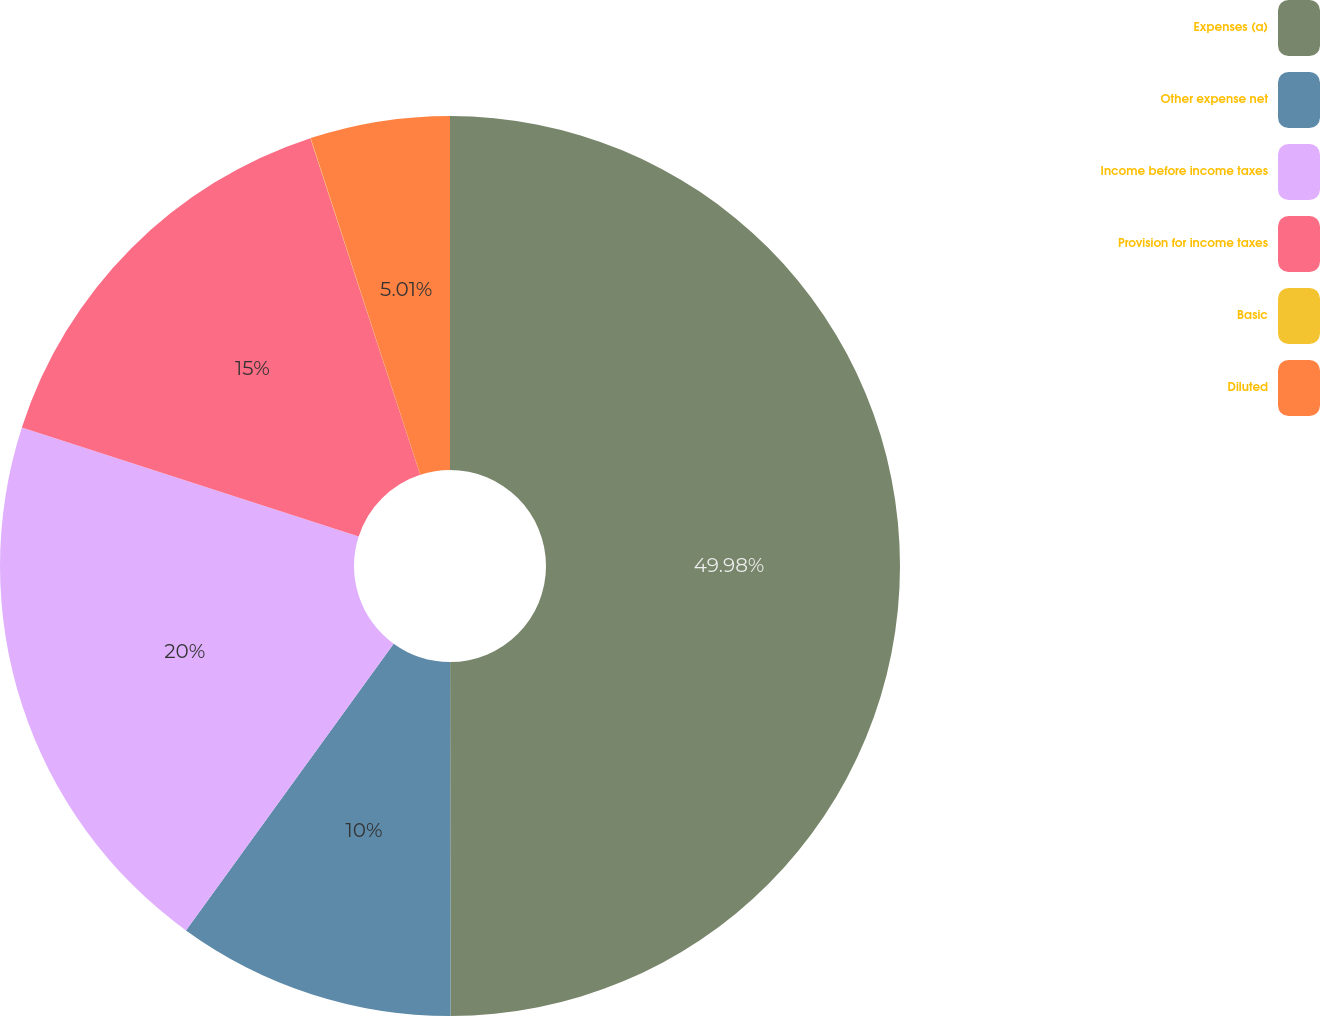Convert chart to OTSL. <chart><loc_0><loc_0><loc_500><loc_500><pie_chart><fcel>Expenses (a)<fcel>Other expense net<fcel>Income before income taxes<fcel>Provision for income taxes<fcel>Basic<fcel>Diluted<nl><fcel>49.98%<fcel>10.0%<fcel>20.0%<fcel>15.0%<fcel>0.01%<fcel>5.01%<nl></chart> 